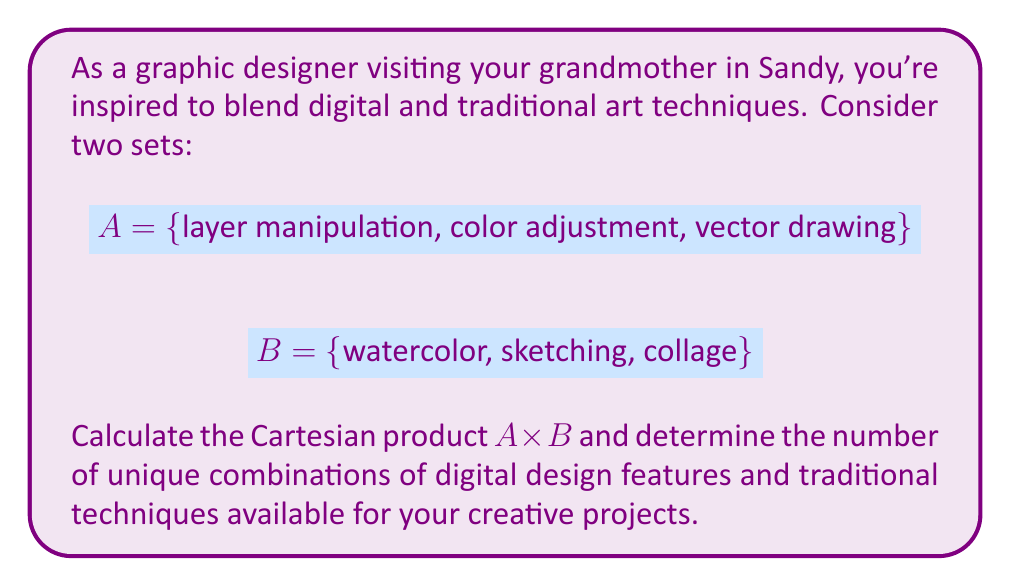Show me your answer to this math problem. Let's approach this step-by-step:

1) The Cartesian product $A \times B$ is defined as the set of all ordered pairs $(a,b)$ where $a \in A$ and $b \in B$.

2) We can visualize this as a grid:

   [asy]
   unitsize(1cm);
   for(int i=0; i<4; ++i) {
     draw((0,i)--(3,i));
     draw((i,0)--(i,3));
   }
   label("layer manipulation", (0.5,3.5));
   label("color adjustment", (1.5,3.5));
   label("vector drawing", (2.5,3.5));
   label("watercolor", (-1,2.5));
   label("sketching", (-1,1.5));
   label("collage", (-1,0.5));
   [/asy]

3) Now, let's list all possible combinations:
   - (layer manipulation, watercolor)
   - (layer manipulation, sketching)
   - (layer manipulation, collage)
   - (color adjustment, watercolor)
   - (color adjustment, sketching)
   - (color adjustment, collage)
   - (vector drawing, watercolor)
   - (vector drawing, sketching)
   - (vector drawing, collage)

4) To calculate the number of elements in the Cartesian product, we multiply the number of elements in each set:
   $$|A \times B| = |A| \cdot |B| = 3 \cdot 3 = 9$$

Thus, there are 9 unique combinations of digital design features and traditional techniques available.
Answer: 9 